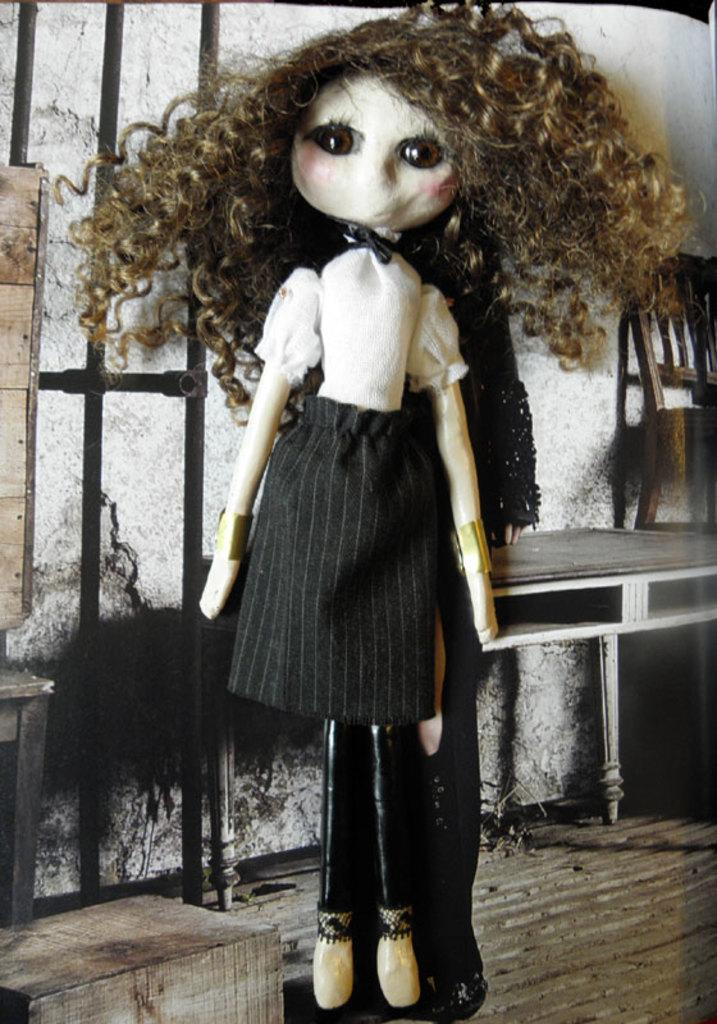What is the main subject of the image? There is a doll in the image. Can you describe the doll's appearance? The doll's hair is messy. What furniture is present in the image? There is a table and a chair in the image. What type of zebra can be seen playing with a spade in the image? There is no zebra or spade present in the image; it features a doll with messy hair and furniture. 